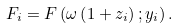Convert formula to latex. <formula><loc_0><loc_0><loc_500><loc_500>F _ { i } = F \left ( \omega \left ( 1 + z _ { i } \right ) ; y _ { i } \right ) .</formula> 